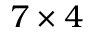Convert formula to latex. <formula><loc_0><loc_0><loc_500><loc_500>7 \times 4</formula> 